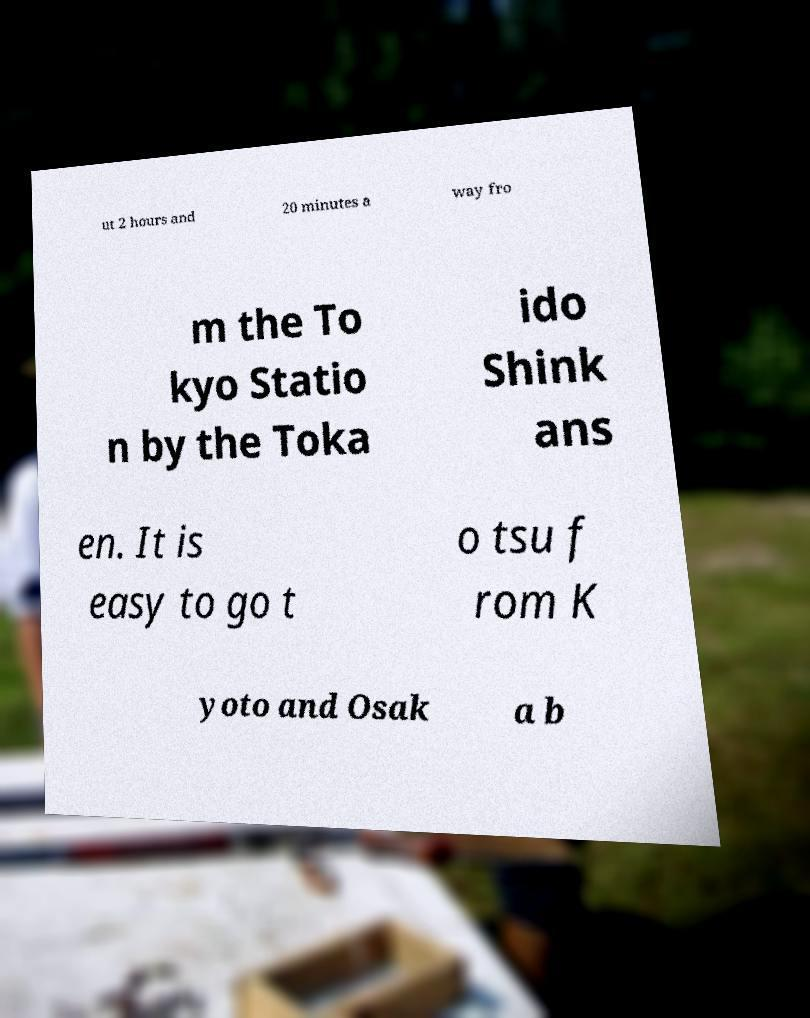Please read and relay the text visible in this image. What does it say? ut 2 hours and 20 minutes a way fro m the To kyo Statio n by the Toka ido Shink ans en. It is easy to go t o tsu f rom K yoto and Osak a b 